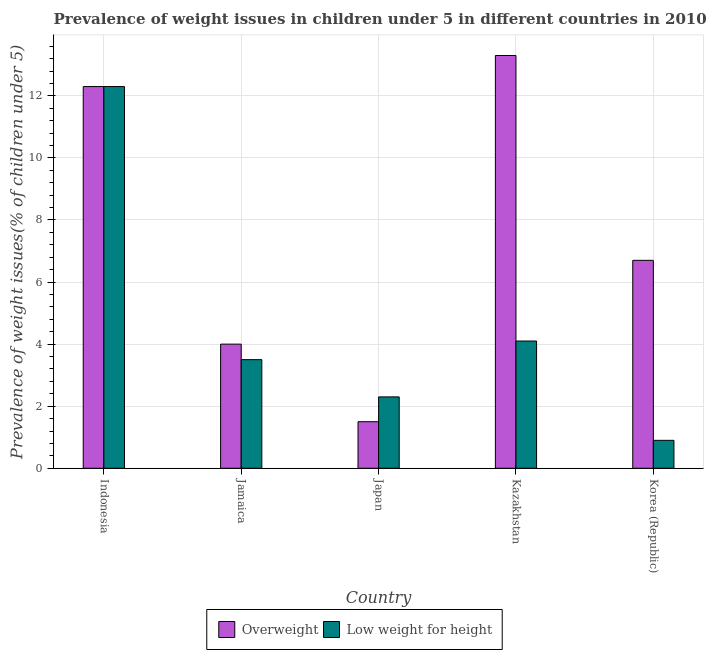How many different coloured bars are there?
Provide a short and direct response. 2. Are the number of bars on each tick of the X-axis equal?
Offer a terse response. Yes. How many bars are there on the 5th tick from the left?
Provide a succinct answer. 2. How many bars are there on the 5th tick from the right?
Provide a succinct answer. 2. What is the label of the 4th group of bars from the left?
Ensure brevity in your answer.  Kazakhstan. What is the percentage of underweight children in Indonesia?
Provide a succinct answer. 12.3. Across all countries, what is the maximum percentage of underweight children?
Your answer should be very brief. 12.3. In which country was the percentage of overweight children maximum?
Give a very brief answer. Kazakhstan. In which country was the percentage of overweight children minimum?
Keep it short and to the point. Japan. What is the total percentage of overweight children in the graph?
Your response must be concise. 37.8. What is the difference between the percentage of underweight children in Indonesia and that in Korea (Republic)?
Offer a terse response. 11.4. What is the difference between the percentage of overweight children in Indonesia and the percentage of underweight children in Korea (Republic)?
Make the answer very short. 11.4. What is the average percentage of overweight children per country?
Provide a succinct answer. 7.56. What is the difference between the percentage of overweight children and percentage of underweight children in Japan?
Keep it short and to the point. -0.8. What is the ratio of the percentage of underweight children in Jamaica to that in Korea (Republic)?
Your response must be concise. 3.89. Is the difference between the percentage of underweight children in Indonesia and Kazakhstan greater than the difference between the percentage of overweight children in Indonesia and Kazakhstan?
Your answer should be compact. Yes. What is the difference between the highest and the second highest percentage of underweight children?
Your answer should be very brief. 8.2. What is the difference between the highest and the lowest percentage of overweight children?
Give a very brief answer. 11.8. In how many countries, is the percentage of overweight children greater than the average percentage of overweight children taken over all countries?
Provide a succinct answer. 2. Is the sum of the percentage of overweight children in Indonesia and Korea (Republic) greater than the maximum percentage of underweight children across all countries?
Your response must be concise. Yes. What does the 2nd bar from the left in Korea (Republic) represents?
Make the answer very short. Low weight for height. What does the 2nd bar from the right in Jamaica represents?
Give a very brief answer. Overweight. How many bars are there?
Make the answer very short. 10. What is the difference between two consecutive major ticks on the Y-axis?
Keep it short and to the point. 2. Does the graph contain grids?
Keep it short and to the point. Yes. How many legend labels are there?
Give a very brief answer. 2. How are the legend labels stacked?
Keep it short and to the point. Horizontal. What is the title of the graph?
Your answer should be very brief. Prevalence of weight issues in children under 5 in different countries in 2010. Does "Non-solid fuel" appear as one of the legend labels in the graph?
Ensure brevity in your answer.  No. What is the label or title of the Y-axis?
Provide a short and direct response. Prevalence of weight issues(% of children under 5). What is the Prevalence of weight issues(% of children under 5) of Overweight in Indonesia?
Keep it short and to the point. 12.3. What is the Prevalence of weight issues(% of children under 5) in Low weight for height in Indonesia?
Your answer should be very brief. 12.3. What is the Prevalence of weight issues(% of children under 5) of Low weight for height in Japan?
Ensure brevity in your answer.  2.3. What is the Prevalence of weight issues(% of children under 5) in Overweight in Kazakhstan?
Ensure brevity in your answer.  13.3. What is the Prevalence of weight issues(% of children under 5) in Low weight for height in Kazakhstan?
Your answer should be compact. 4.1. What is the Prevalence of weight issues(% of children under 5) of Overweight in Korea (Republic)?
Keep it short and to the point. 6.7. What is the Prevalence of weight issues(% of children under 5) of Low weight for height in Korea (Republic)?
Your answer should be very brief. 0.9. Across all countries, what is the maximum Prevalence of weight issues(% of children under 5) of Overweight?
Offer a terse response. 13.3. Across all countries, what is the maximum Prevalence of weight issues(% of children under 5) in Low weight for height?
Your response must be concise. 12.3. Across all countries, what is the minimum Prevalence of weight issues(% of children under 5) in Overweight?
Your response must be concise. 1.5. Across all countries, what is the minimum Prevalence of weight issues(% of children under 5) in Low weight for height?
Make the answer very short. 0.9. What is the total Prevalence of weight issues(% of children under 5) of Overweight in the graph?
Your answer should be very brief. 37.8. What is the total Prevalence of weight issues(% of children under 5) in Low weight for height in the graph?
Your answer should be very brief. 23.1. What is the difference between the Prevalence of weight issues(% of children under 5) of Overweight in Indonesia and that in Jamaica?
Give a very brief answer. 8.3. What is the difference between the Prevalence of weight issues(% of children under 5) in Overweight in Indonesia and that in Kazakhstan?
Make the answer very short. -1. What is the difference between the Prevalence of weight issues(% of children under 5) in Low weight for height in Jamaica and that in Japan?
Keep it short and to the point. 1.2. What is the difference between the Prevalence of weight issues(% of children under 5) of Low weight for height in Jamaica and that in Kazakhstan?
Your response must be concise. -0.6. What is the difference between the Prevalence of weight issues(% of children under 5) of Overweight in Jamaica and that in Korea (Republic)?
Offer a very short reply. -2.7. What is the difference between the Prevalence of weight issues(% of children under 5) in Overweight in Japan and that in Kazakhstan?
Give a very brief answer. -11.8. What is the difference between the Prevalence of weight issues(% of children under 5) in Overweight in Indonesia and the Prevalence of weight issues(% of children under 5) in Low weight for height in Jamaica?
Give a very brief answer. 8.8. What is the difference between the Prevalence of weight issues(% of children under 5) of Overweight in Indonesia and the Prevalence of weight issues(% of children under 5) of Low weight for height in Japan?
Ensure brevity in your answer.  10. What is the difference between the Prevalence of weight issues(% of children under 5) of Overweight in Indonesia and the Prevalence of weight issues(% of children under 5) of Low weight for height in Kazakhstan?
Keep it short and to the point. 8.2. What is the difference between the Prevalence of weight issues(% of children under 5) of Overweight in Jamaica and the Prevalence of weight issues(% of children under 5) of Low weight for height in Japan?
Your response must be concise. 1.7. What is the difference between the Prevalence of weight issues(% of children under 5) in Overweight in Japan and the Prevalence of weight issues(% of children under 5) in Low weight for height in Korea (Republic)?
Your response must be concise. 0.6. What is the difference between the Prevalence of weight issues(% of children under 5) of Overweight in Kazakhstan and the Prevalence of weight issues(% of children under 5) of Low weight for height in Korea (Republic)?
Your answer should be very brief. 12.4. What is the average Prevalence of weight issues(% of children under 5) in Overweight per country?
Provide a short and direct response. 7.56. What is the average Prevalence of weight issues(% of children under 5) of Low weight for height per country?
Offer a very short reply. 4.62. What is the difference between the Prevalence of weight issues(% of children under 5) in Overweight and Prevalence of weight issues(% of children under 5) in Low weight for height in Indonesia?
Provide a short and direct response. 0. What is the difference between the Prevalence of weight issues(% of children under 5) of Overweight and Prevalence of weight issues(% of children under 5) of Low weight for height in Japan?
Give a very brief answer. -0.8. What is the difference between the Prevalence of weight issues(% of children under 5) of Overweight and Prevalence of weight issues(% of children under 5) of Low weight for height in Korea (Republic)?
Give a very brief answer. 5.8. What is the ratio of the Prevalence of weight issues(% of children under 5) in Overweight in Indonesia to that in Jamaica?
Make the answer very short. 3.08. What is the ratio of the Prevalence of weight issues(% of children under 5) of Low weight for height in Indonesia to that in Jamaica?
Offer a very short reply. 3.51. What is the ratio of the Prevalence of weight issues(% of children under 5) of Low weight for height in Indonesia to that in Japan?
Offer a very short reply. 5.35. What is the ratio of the Prevalence of weight issues(% of children under 5) of Overweight in Indonesia to that in Kazakhstan?
Your answer should be very brief. 0.92. What is the ratio of the Prevalence of weight issues(% of children under 5) in Low weight for height in Indonesia to that in Kazakhstan?
Provide a short and direct response. 3. What is the ratio of the Prevalence of weight issues(% of children under 5) of Overweight in Indonesia to that in Korea (Republic)?
Your response must be concise. 1.84. What is the ratio of the Prevalence of weight issues(% of children under 5) of Low weight for height in Indonesia to that in Korea (Republic)?
Provide a succinct answer. 13.67. What is the ratio of the Prevalence of weight issues(% of children under 5) of Overweight in Jamaica to that in Japan?
Keep it short and to the point. 2.67. What is the ratio of the Prevalence of weight issues(% of children under 5) in Low weight for height in Jamaica to that in Japan?
Your answer should be compact. 1.52. What is the ratio of the Prevalence of weight issues(% of children under 5) in Overweight in Jamaica to that in Kazakhstan?
Offer a terse response. 0.3. What is the ratio of the Prevalence of weight issues(% of children under 5) of Low weight for height in Jamaica to that in Kazakhstan?
Give a very brief answer. 0.85. What is the ratio of the Prevalence of weight issues(% of children under 5) in Overweight in Jamaica to that in Korea (Republic)?
Provide a succinct answer. 0.6. What is the ratio of the Prevalence of weight issues(% of children under 5) of Low weight for height in Jamaica to that in Korea (Republic)?
Your answer should be very brief. 3.89. What is the ratio of the Prevalence of weight issues(% of children under 5) in Overweight in Japan to that in Kazakhstan?
Your answer should be compact. 0.11. What is the ratio of the Prevalence of weight issues(% of children under 5) in Low weight for height in Japan to that in Kazakhstan?
Make the answer very short. 0.56. What is the ratio of the Prevalence of weight issues(% of children under 5) in Overweight in Japan to that in Korea (Republic)?
Offer a very short reply. 0.22. What is the ratio of the Prevalence of weight issues(% of children under 5) in Low weight for height in Japan to that in Korea (Republic)?
Make the answer very short. 2.56. What is the ratio of the Prevalence of weight issues(% of children under 5) in Overweight in Kazakhstan to that in Korea (Republic)?
Your answer should be very brief. 1.99. What is the ratio of the Prevalence of weight issues(% of children under 5) in Low weight for height in Kazakhstan to that in Korea (Republic)?
Your response must be concise. 4.56. What is the difference between the highest and the second highest Prevalence of weight issues(% of children under 5) in Low weight for height?
Your answer should be very brief. 8.2. What is the difference between the highest and the lowest Prevalence of weight issues(% of children under 5) of Low weight for height?
Ensure brevity in your answer.  11.4. 